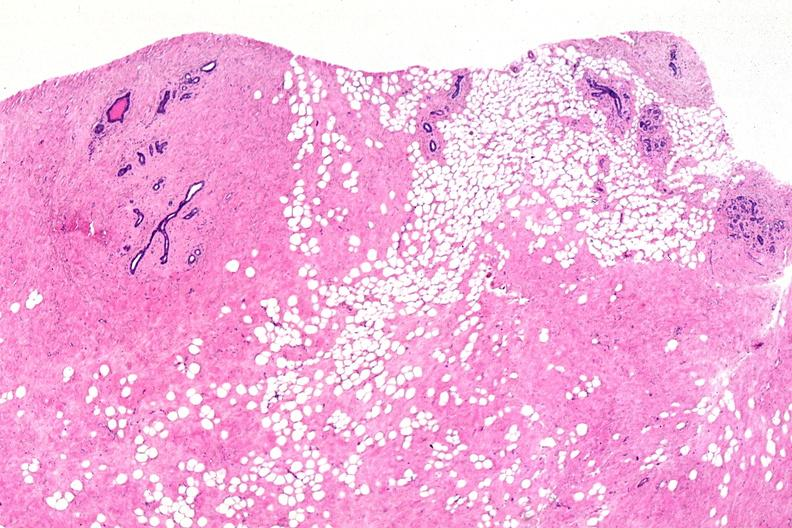where is this from?
Answer the question using a single word or phrase. Female reproductive system 